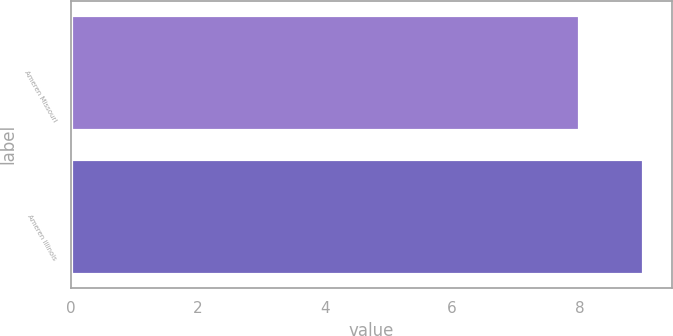<chart> <loc_0><loc_0><loc_500><loc_500><bar_chart><fcel>Ameren Missouri<fcel>Ameren Illinois<nl><fcel>8<fcel>9<nl></chart> 